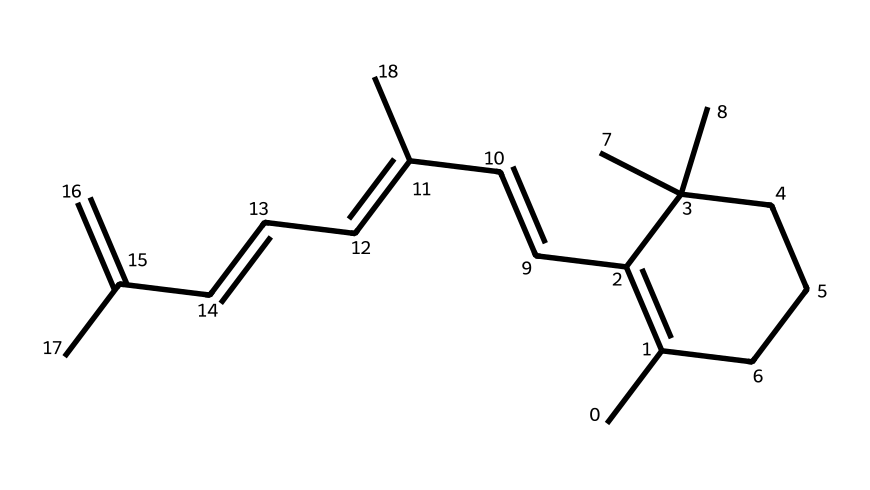What is the molecular formula of this compound? By analyzing the SMILES representation, we count the carbon (C) and hydrogen (H) atoms present. The structure indicates a molecular formula with 30 carbon atoms and 50 hydrogen atoms, leading us to determine the formula as C30H50.
Answer: C30H50 How many double bonds are in this structure? In the chemical structure depicted by the SMILES, we can identify areas where carbons are connected with double bonds; these are typically indicated by the equal signs in a drawn structure. Here, there are 5 double bonds observed.
Answer: 5 What type of isomerism is exhibited in this compound? Given that the compound has multiple double bonds with substituents that can be arranged differently around those double bonds, this compound exemplifies geometric isomerism — specifically cis-trans isomerism.
Answer: geometric isomerism How many branched carbon chains are present? By inspecting the structure, we can see various branched carbon chains. The number of distinct branches can be counted, and here we identify 2 branched chains stemming from the main carbon backbone.
Answer: 2 Which geometric configuration is more stable in this compound, cis or trans? In general, trans isomers tend to be more stable than cis due to reduced steric hindrance between substituents. Analyzing the common knowledge around vitamin A structures and properties, we deduce that trans configuration is likely the more stable form.
Answer: trans What is the expected physical state of this compound at room temperature? Given that many compounds with similar molecular weights (like this one) are often oily or liquid-like at room temperature, we can conclude this compound is likely a liquid or oil, as its molecular formula suggests that it is not solid.
Answer: liquid or oil 